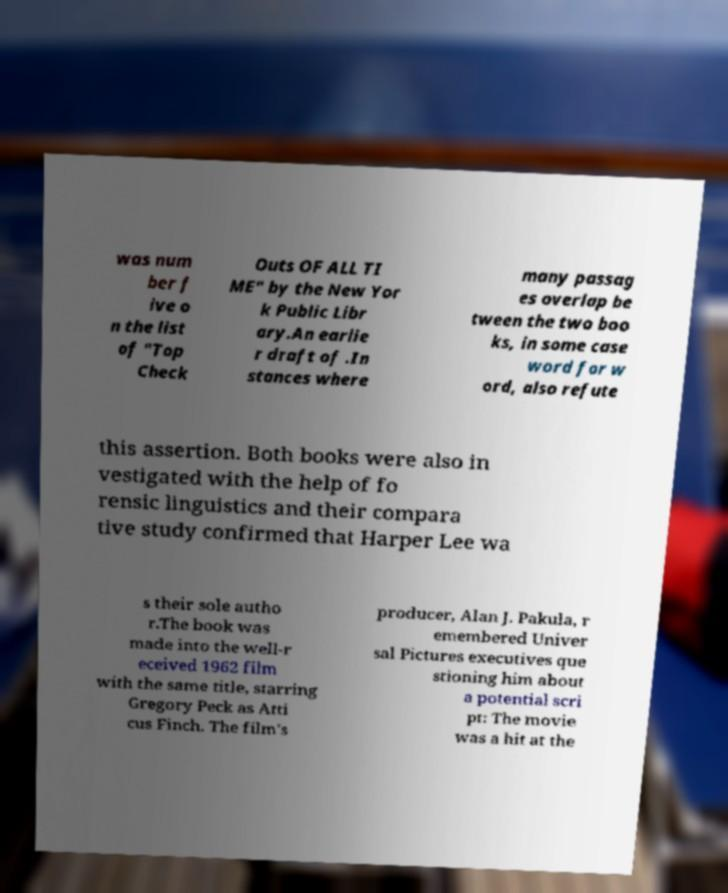Can you read and provide the text displayed in the image?This photo seems to have some interesting text. Can you extract and type it out for me? was num ber f ive o n the list of "Top Check Outs OF ALL TI ME" by the New Yor k Public Libr ary.An earlie r draft of .In stances where many passag es overlap be tween the two boo ks, in some case word for w ord, also refute this assertion. Both books were also in vestigated with the help of fo rensic linguistics and their compara tive study confirmed that Harper Lee wa s their sole autho r.The book was made into the well-r eceived 1962 film with the same title, starring Gregory Peck as Atti cus Finch. The film's producer, Alan J. Pakula, r emembered Univer sal Pictures executives que stioning him about a potential scri pt: The movie was a hit at the 